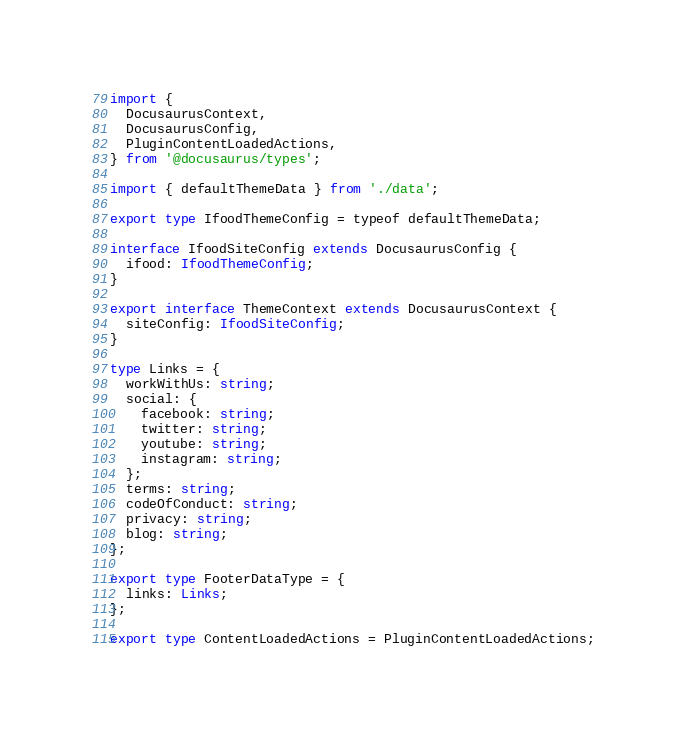Convert code to text. <code><loc_0><loc_0><loc_500><loc_500><_TypeScript_>import {
  DocusaurusContext,
  DocusaurusConfig,
  PluginContentLoadedActions,
} from '@docusaurus/types';

import { defaultThemeData } from './data';

export type IfoodThemeConfig = typeof defaultThemeData;

interface IfoodSiteConfig extends DocusaurusConfig {
  ifood: IfoodThemeConfig;
}

export interface ThemeContext extends DocusaurusContext {
  siteConfig: IfoodSiteConfig;
}

type Links = {
  workWithUs: string;
  social: {
    facebook: string;
    twitter: string;
    youtube: string;
    instagram: string;
  };
  terms: string;
  codeOfConduct: string;
  privacy: string;
  blog: string;
};

export type FooterDataType = {
  links: Links;
};

export type ContentLoadedActions = PluginContentLoadedActions;
</code> 